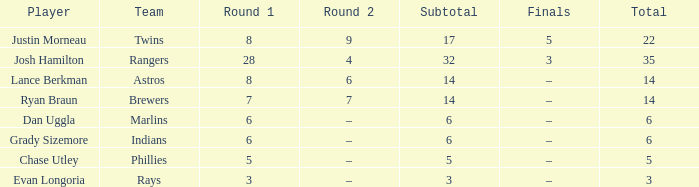Could you parse the entire table as a dict? {'header': ['Player', 'Team', 'Round 1', 'Round 2', 'Subtotal', 'Finals', 'Total'], 'rows': [['Justin Morneau', 'Twins', '8', '9', '17', '5', '22'], ['Josh Hamilton', 'Rangers', '28', '4', '32', '3', '35'], ['Lance Berkman', 'Astros', '8', '6', '14', '–', '14'], ['Ryan Braun', 'Brewers', '7', '7', '14', '–', '14'], ['Dan Uggla', 'Marlins', '6', '–', '6', '–', '6'], ['Grady Sizemore', 'Indians', '6', '–', '6', '–', '6'], ['Chase Utley', 'Phillies', '5', '–', '5', '–', '5'], ['Evan Longoria', 'Rays', '3', '–', '3', '–', '3']]} Which player has a subtotal of more than 3 and more than 8 in round 1? Josh Hamilton. 